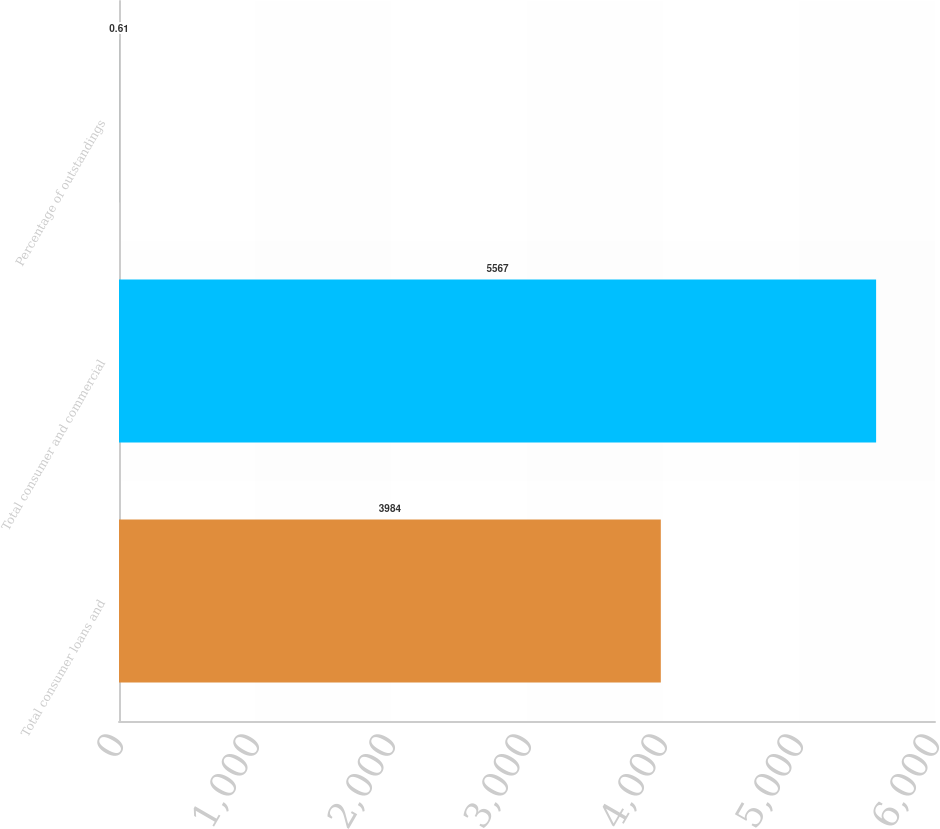<chart> <loc_0><loc_0><loc_500><loc_500><bar_chart><fcel>Total consumer loans and<fcel>Total consumer and commercial<fcel>Percentage of outstandings<nl><fcel>3984<fcel>5567<fcel>0.61<nl></chart> 